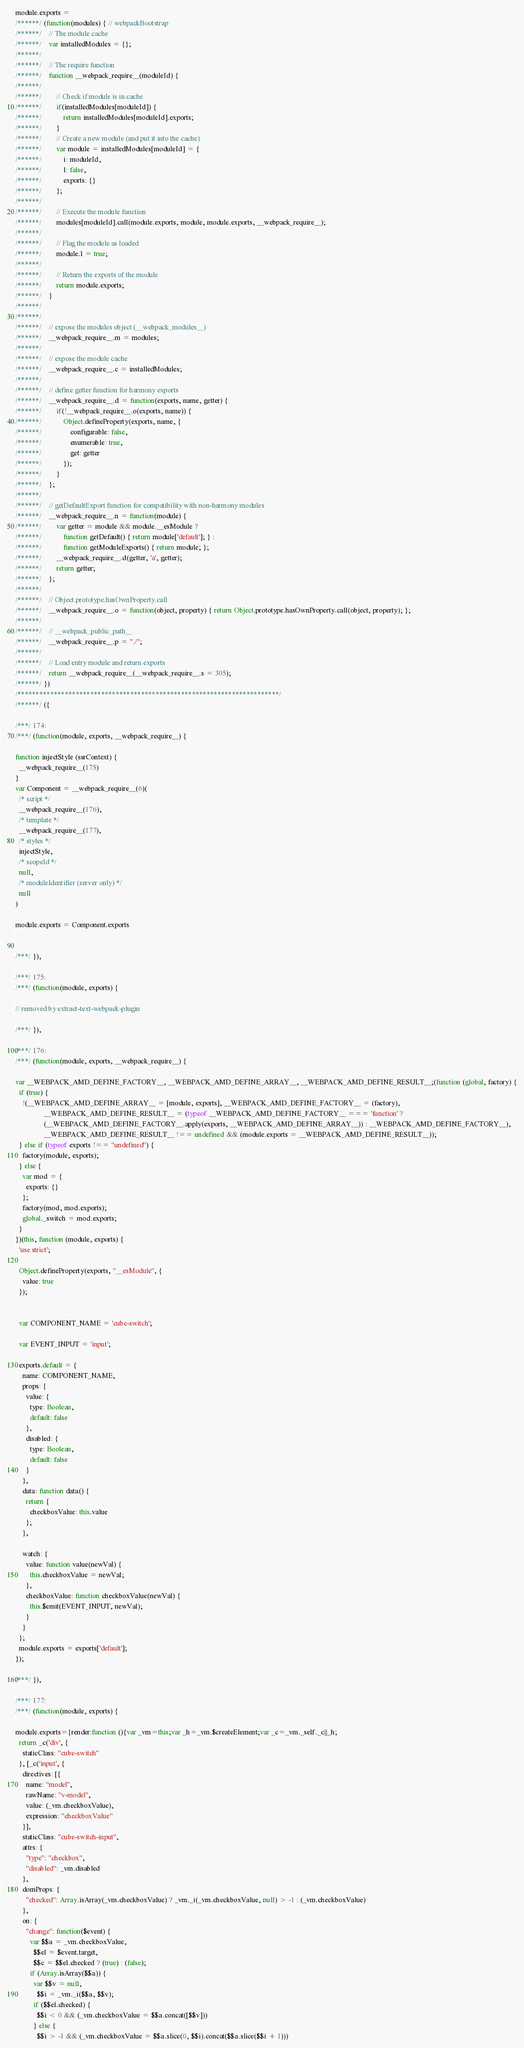<code> <loc_0><loc_0><loc_500><loc_500><_JavaScript_>module.exports =
/******/ (function(modules) { // webpackBootstrap
/******/ 	// The module cache
/******/ 	var installedModules = {};
/******/
/******/ 	// The require function
/******/ 	function __webpack_require__(moduleId) {
/******/
/******/ 		// Check if module is in cache
/******/ 		if(installedModules[moduleId]) {
/******/ 			return installedModules[moduleId].exports;
/******/ 		}
/******/ 		// Create a new module (and put it into the cache)
/******/ 		var module = installedModules[moduleId] = {
/******/ 			i: moduleId,
/******/ 			l: false,
/******/ 			exports: {}
/******/ 		};
/******/
/******/ 		// Execute the module function
/******/ 		modules[moduleId].call(module.exports, module, module.exports, __webpack_require__);
/******/
/******/ 		// Flag the module as loaded
/******/ 		module.l = true;
/******/
/******/ 		// Return the exports of the module
/******/ 		return module.exports;
/******/ 	}
/******/
/******/
/******/ 	// expose the modules object (__webpack_modules__)
/******/ 	__webpack_require__.m = modules;
/******/
/******/ 	// expose the module cache
/******/ 	__webpack_require__.c = installedModules;
/******/
/******/ 	// define getter function for harmony exports
/******/ 	__webpack_require__.d = function(exports, name, getter) {
/******/ 		if(!__webpack_require__.o(exports, name)) {
/******/ 			Object.defineProperty(exports, name, {
/******/ 				configurable: false,
/******/ 				enumerable: true,
/******/ 				get: getter
/******/ 			});
/******/ 		}
/******/ 	};
/******/
/******/ 	// getDefaultExport function for compatibility with non-harmony modules
/******/ 	__webpack_require__.n = function(module) {
/******/ 		var getter = module && module.__esModule ?
/******/ 			function getDefault() { return module['default']; } :
/******/ 			function getModuleExports() { return module; };
/******/ 		__webpack_require__.d(getter, 'a', getter);
/******/ 		return getter;
/******/ 	};
/******/
/******/ 	// Object.prototype.hasOwnProperty.call
/******/ 	__webpack_require__.o = function(object, property) { return Object.prototype.hasOwnProperty.call(object, property); };
/******/
/******/ 	// __webpack_public_path__
/******/ 	__webpack_require__.p = "./";
/******/
/******/ 	// Load entry module and return exports
/******/ 	return __webpack_require__(__webpack_require__.s = 305);
/******/ })
/************************************************************************/
/******/ ({

/***/ 174:
/***/ (function(module, exports, __webpack_require__) {

function injectStyle (ssrContext) {
  __webpack_require__(175)
}
var Component = __webpack_require__(6)(
  /* script */
  __webpack_require__(176),
  /* template */
  __webpack_require__(177),
  /* styles */
  injectStyle,
  /* scopeId */
  null,
  /* moduleIdentifier (server only) */
  null
)

module.exports = Component.exports


/***/ }),

/***/ 175:
/***/ (function(module, exports) {

// removed by extract-text-webpack-plugin

/***/ }),

/***/ 176:
/***/ (function(module, exports, __webpack_require__) {

var __WEBPACK_AMD_DEFINE_FACTORY__, __WEBPACK_AMD_DEFINE_ARRAY__, __WEBPACK_AMD_DEFINE_RESULT__;(function (global, factory) {
  if (true) {
    !(__WEBPACK_AMD_DEFINE_ARRAY__ = [module, exports], __WEBPACK_AMD_DEFINE_FACTORY__ = (factory),
				__WEBPACK_AMD_DEFINE_RESULT__ = (typeof __WEBPACK_AMD_DEFINE_FACTORY__ === 'function' ?
				(__WEBPACK_AMD_DEFINE_FACTORY__.apply(exports, __WEBPACK_AMD_DEFINE_ARRAY__)) : __WEBPACK_AMD_DEFINE_FACTORY__),
				__WEBPACK_AMD_DEFINE_RESULT__ !== undefined && (module.exports = __WEBPACK_AMD_DEFINE_RESULT__));
  } else if (typeof exports !== "undefined") {
    factory(module, exports);
  } else {
    var mod = {
      exports: {}
    };
    factory(mod, mod.exports);
    global._switch = mod.exports;
  }
})(this, function (module, exports) {
  'use strict';

  Object.defineProperty(exports, "__esModule", {
    value: true
  });


  var COMPONENT_NAME = 'cube-switch';

  var EVENT_INPUT = 'input';

  exports.default = {
    name: COMPONENT_NAME,
    props: {
      value: {
        type: Boolean,
        default: false
      },
      disabled: {
        type: Boolean,
        default: false
      }
    },
    data: function data() {
      return {
        checkboxValue: this.value
      };
    },

    watch: {
      value: function value(newVal) {
        this.checkboxValue = newVal;
      },
      checkboxValue: function checkboxValue(newVal) {
        this.$emit(EVENT_INPUT, newVal);
      }
    }
  };
  module.exports = exports['default'];
});

/***/ }),

/***/ 177:
/***/ (function(module, exports) {

module.exports={render:function (){var _vm=this;var _h=_vm.$createElement;var _c=_vm._self._c||_h;
  return _c('div', {
    staticClass: "cube-switch"
  }, [_c('input', {
    directives: [{
      name: "model",
      rawName: "v-model",
      value: (_vm.checkboxValue),
      expression: "checkboxValue"
    }],
    staticClass: "cube-switch-input",
    attrs: {
      "type": "checkbox",
      "disabled": _vm.disabled
    },
    domProps: {
      "checked": Array.isArray(_vm.checkboxValue) ? _vm._i(_vm.checkboxValue, null) > -1 : (_vm.checkboxValue)
    },
    on: {
      "change": function($event) {
        var $$a = _vm.checkboxValue,
          $$el = $event.target,
          $$c = $$el.checked ? (true) : (false);
        if (Array.isArray($$a)) {
          var $$v = null,
            $$i = _vm._i($$a, $$v);
          if ($$el.checked) {
            $$i < 0 && (_vm.checkboxValue = $$a.concat([$$v]))
          } else {
            $$i > -1 && (_vm.checkboxValue = $$a.slice(0, $$i).concat($$a.slice($$i + 1)))</code> 